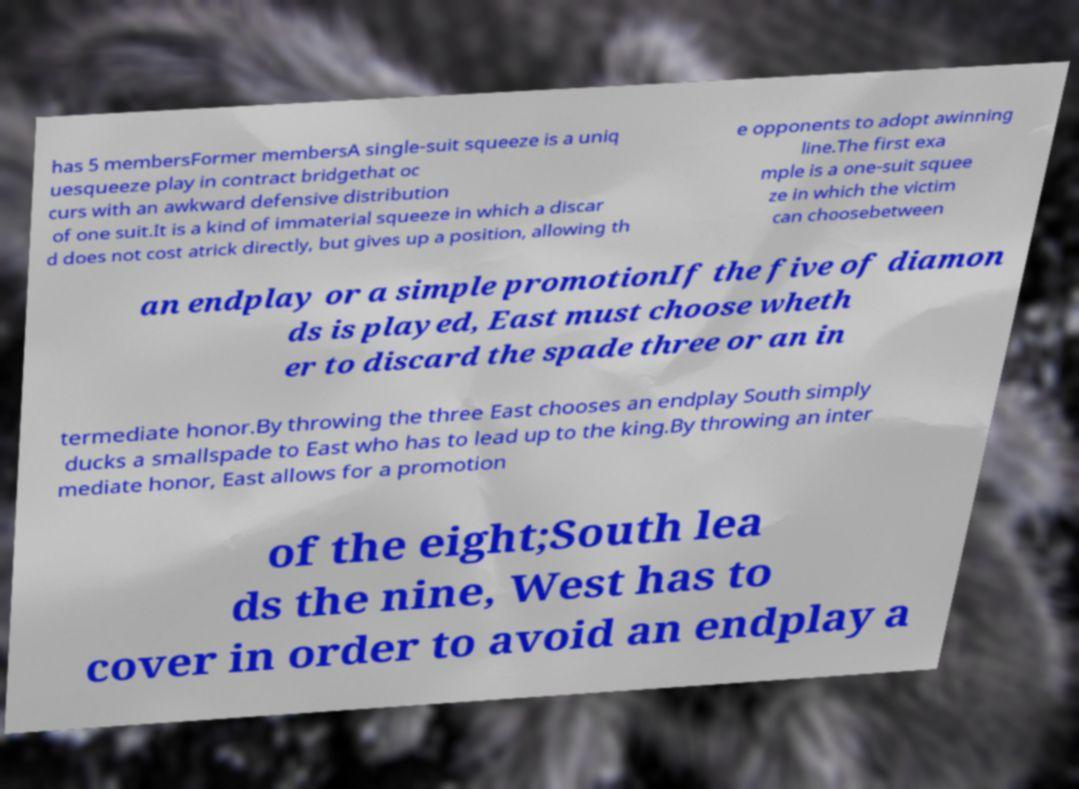What messages or text are displayed in this image? I need them in a readable, typed format. has 5 membersFormer membersA single-suit squeeze is a uniq uesqueeze play in contract bridgethat oc curs with an awkward defensive distribution of one suit.It is a kind of immaterial squeeze in which a discar d does not cost atrick directly, but gives up a position, allowing th e opponents to adopt awinning line.The first exa mple is a one-suit squee ze in which the victim can choosebetween an endplay or a simple promotionIf the five of diamon ds is played, East must choose wheth er to discard the spade three or an in termediate honor.By throwing the three East chooses an endplay South simply ducks a smallspade to East who has to lead up to the king.By throwing an inter mediate honor, East allows for a promotion of the eight;South lea ds the nine, West has to cover in order to avoid an endplay a 